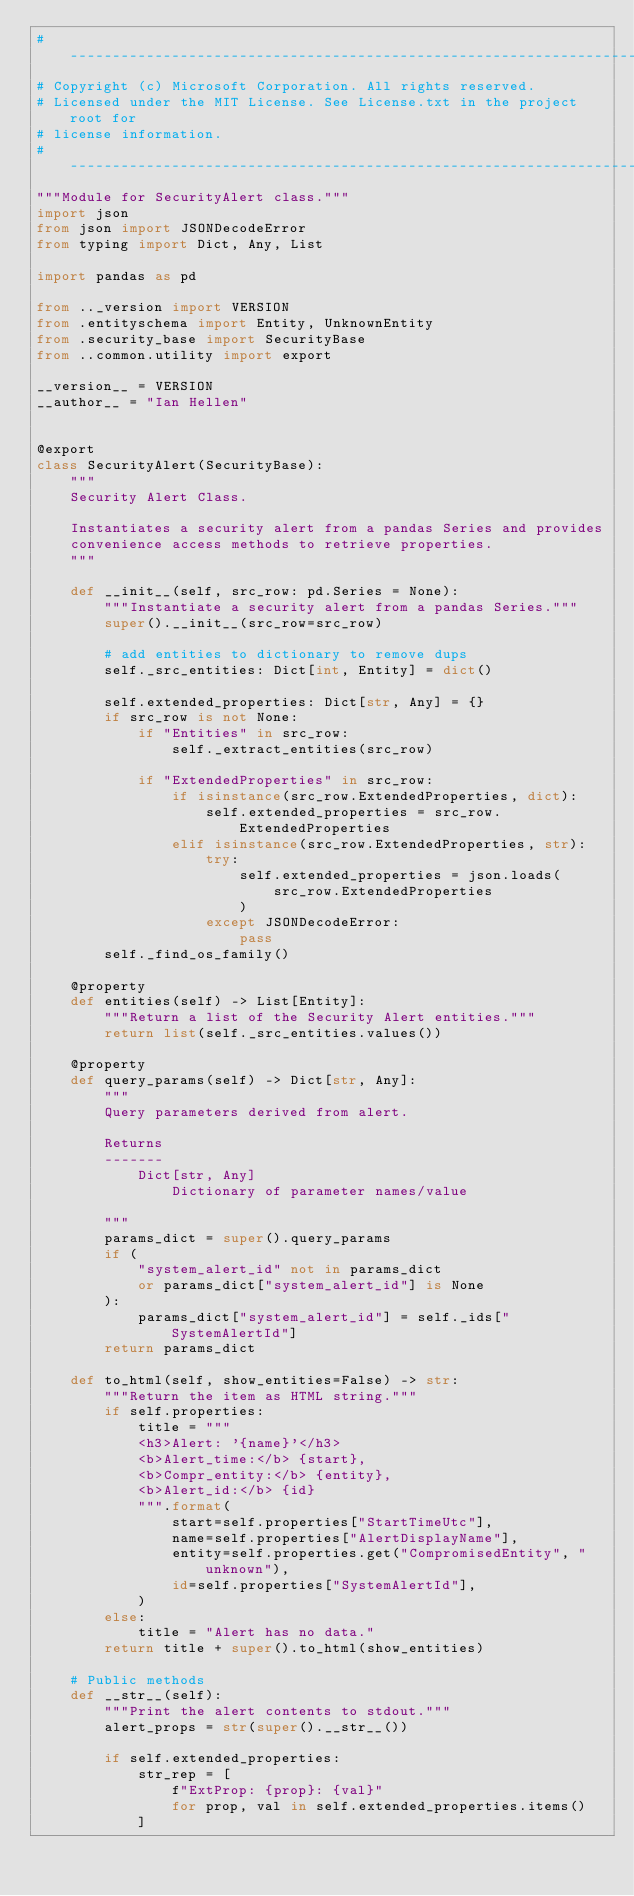<code> <loc_0><loc_0><loc_500><loc_500><_Python_># -------------------------------------------------------------------------
# Copyright (c) Microsoft Corporation. All rights reserved.
# Licensed under the MIT License. See License.txt in the project root for
# license information.
# --------------------------------------------------------------------------
"""Module for SecurityAlert class."""
import json
from json import JSONDecodeError
from typing import Dict, Any, List

import pandas as pd

from .._version import VERSION
from .entityschema import Entity, UnknownEntity
from .security_base import SecurityBase
from ..common.utility import export

__version__ = VERSION
__author__ = "Ian Hellen"


@export
class SecurityAlert(SecurityBase):
    """
    Security Alert Class.

    Instantiates a security alert from a pandas Series and provides
    convenience access methods to retrieve properties.
    """

    def __init__(self, src_row: pd.Series = None):
        """Instantiate a security alert from a pandas Series."""
        super().__init__(src_row=src_row)

        # add entities to dictionary to remove dups
        self._src_entities: Dict[int, Entity] = dict()

        self.extended_properties: Dict[str, Any] = {}
        if src_row is not None:
            if "Entities" in src_row:
                self._extract_entities(src_row)

            if "ExtendedProperties" in src_row:
                if isinstance(src_row.ExtendedProperties, dict):
                    self.extended_properties = src_row.ExtendedProperties
                elif isinstance(src_row.ExtendedProperties, str):
                    try:
                        self.extended_properties = json.loads(
                            src_row.ExtendedProperties
                        )
                    except JSONDecodeError:
                        pass
        self._find_os_family()

    @property
    def entities(self) -> List[Entity]:
        """Return a list of the Security Alert entities."""
        return list(self._src_entities.values())

    @property
    def query_params(self) -> Dict[str, Any]:
        """
        Query parameters derived from alert.

        Returns
        -------
            Dict[str, Any]
                Dictionary of parameter names/value

        """
        params_dict = super().query_params
        if (
            "system_alert_id" not in params_dict
            or params_dict["system_alert_id"] is None
        ):
            params_dict["system_alert_id"] = self._ids["SystemAlertId"]
        return params_dict

    def to_html(self, show_entities=False) -> str:
        """Return the item as HTML string."""
        if self.properties:
            title = """
            <h3>Alert: '{name}'</h3>
            <b>Alert_time:</b> {start},
            <b>Compr_entity:</b> {entity},
            <b>Alert_id:</b> {id}
            """.format(
                start=self.properties["StartTimeUtc"],
                name=self.properties["AlertDisplayName"],
                entity=self.properties.get("CompromisedEntity", "unknown"),
                id=self.properties["SystemAlertId"],
            )
        else:
            title = "Alert has no data."
        return title + super().to_html(show_entities)

    # Public methods
    def __str__(self):
        """Print the alert contents to stdout."""
        alert_props = str(super().__str__())

        if self.extended_properties:
            str_rep = [
                f"ExtProp: {prop}: {val}"
                for prop, val in self.extended_properties.items()
            ]</code> 